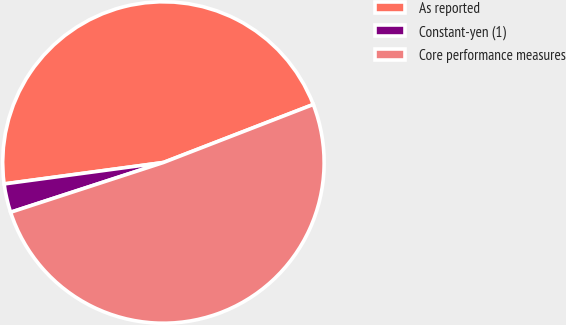<chart> <loc_0><loc_0><loc_500><loc_500><pie_chart><fcel>As reported<fcel>Constant-yen (1)<fcel>Core performance measures<nl><fcel>46.25%<fcel>2.88%<fcel>50.87%<nl></chart> 